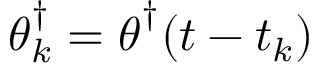<formula> <loc_0><loc_0><loc_500><loc_500>\theta _ { k } ^ { \dagger } = \theta ^ { \dagger } ( t - t _ { k } )</formula> 